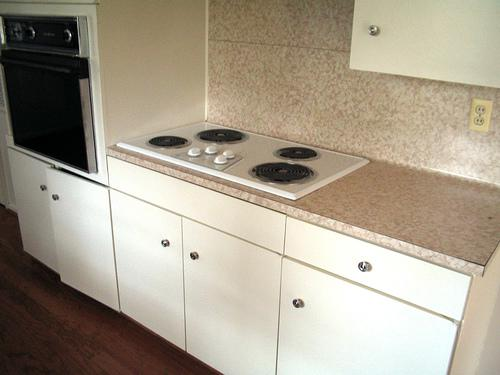Question: how many burners are on the stove?
Choices:
A. Two.
B. Three.
C. Six.
D. Four.
Answer with the letter. Answer: D Question: where was this picture taken?
Choices:
A. In a bathroom.
B. In a bedroom.
C. In a kitchen.
D. Outside.
Answer with the letter. Answer: C Question: what color are the door knobs?
Choices:
A. Silver.
B. Gold.
C. Bronze.
D. Platinum.
Answer with the letter. Answer: A Question: what is this space used for?
Choices:
A. Watching television.
B. Sleeping.
C. Exercising.
D. Cooking food.
Answer with the letter. Answer: D 